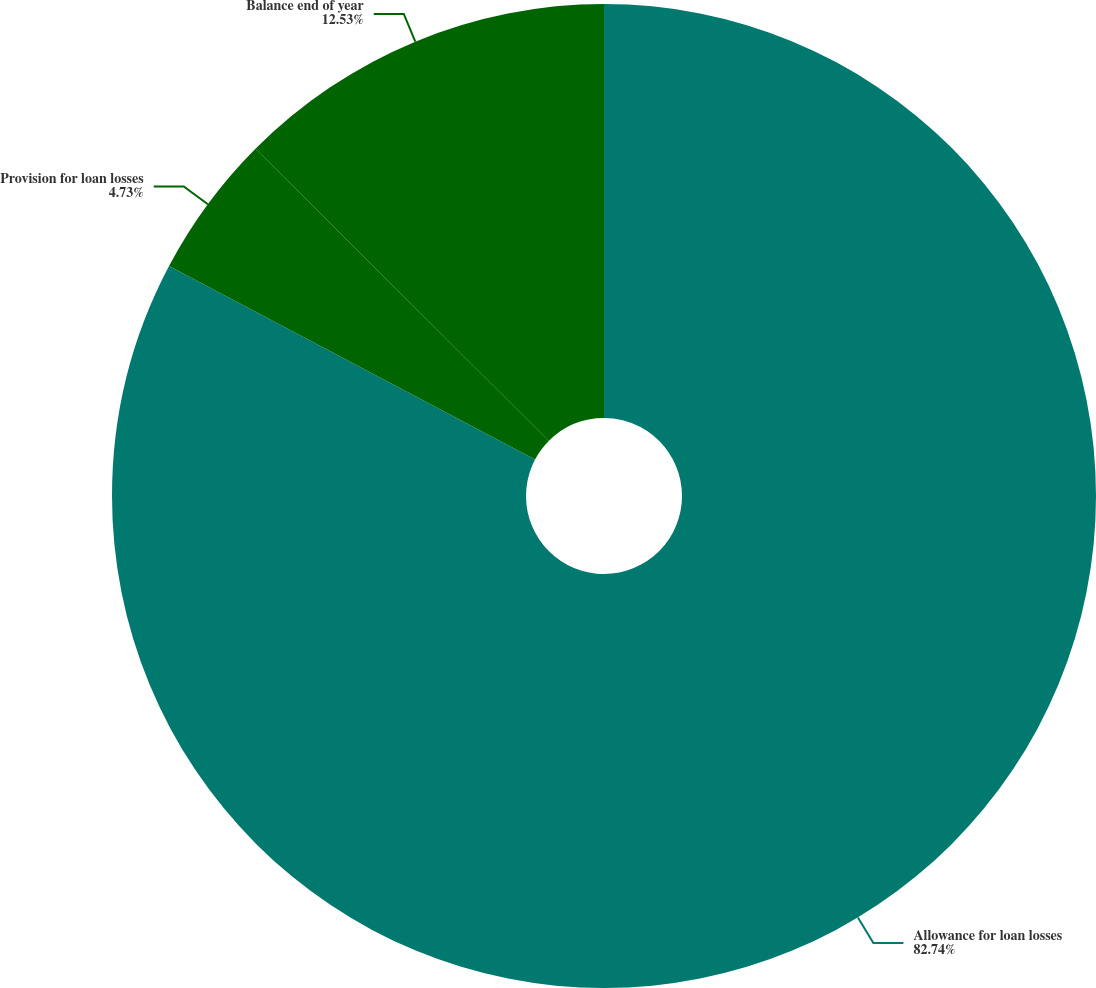Convert chart to OTSL. <chart><loc_0><loc_0><loc_500><loc_500><pie_chart><fcel>Allowance for loan losses<fcel>Provision for loan losses<fcel>Balance end of year<nl><fcel>82.74%<fcel>4.73%<fcel>12.53%<nl></chart> 